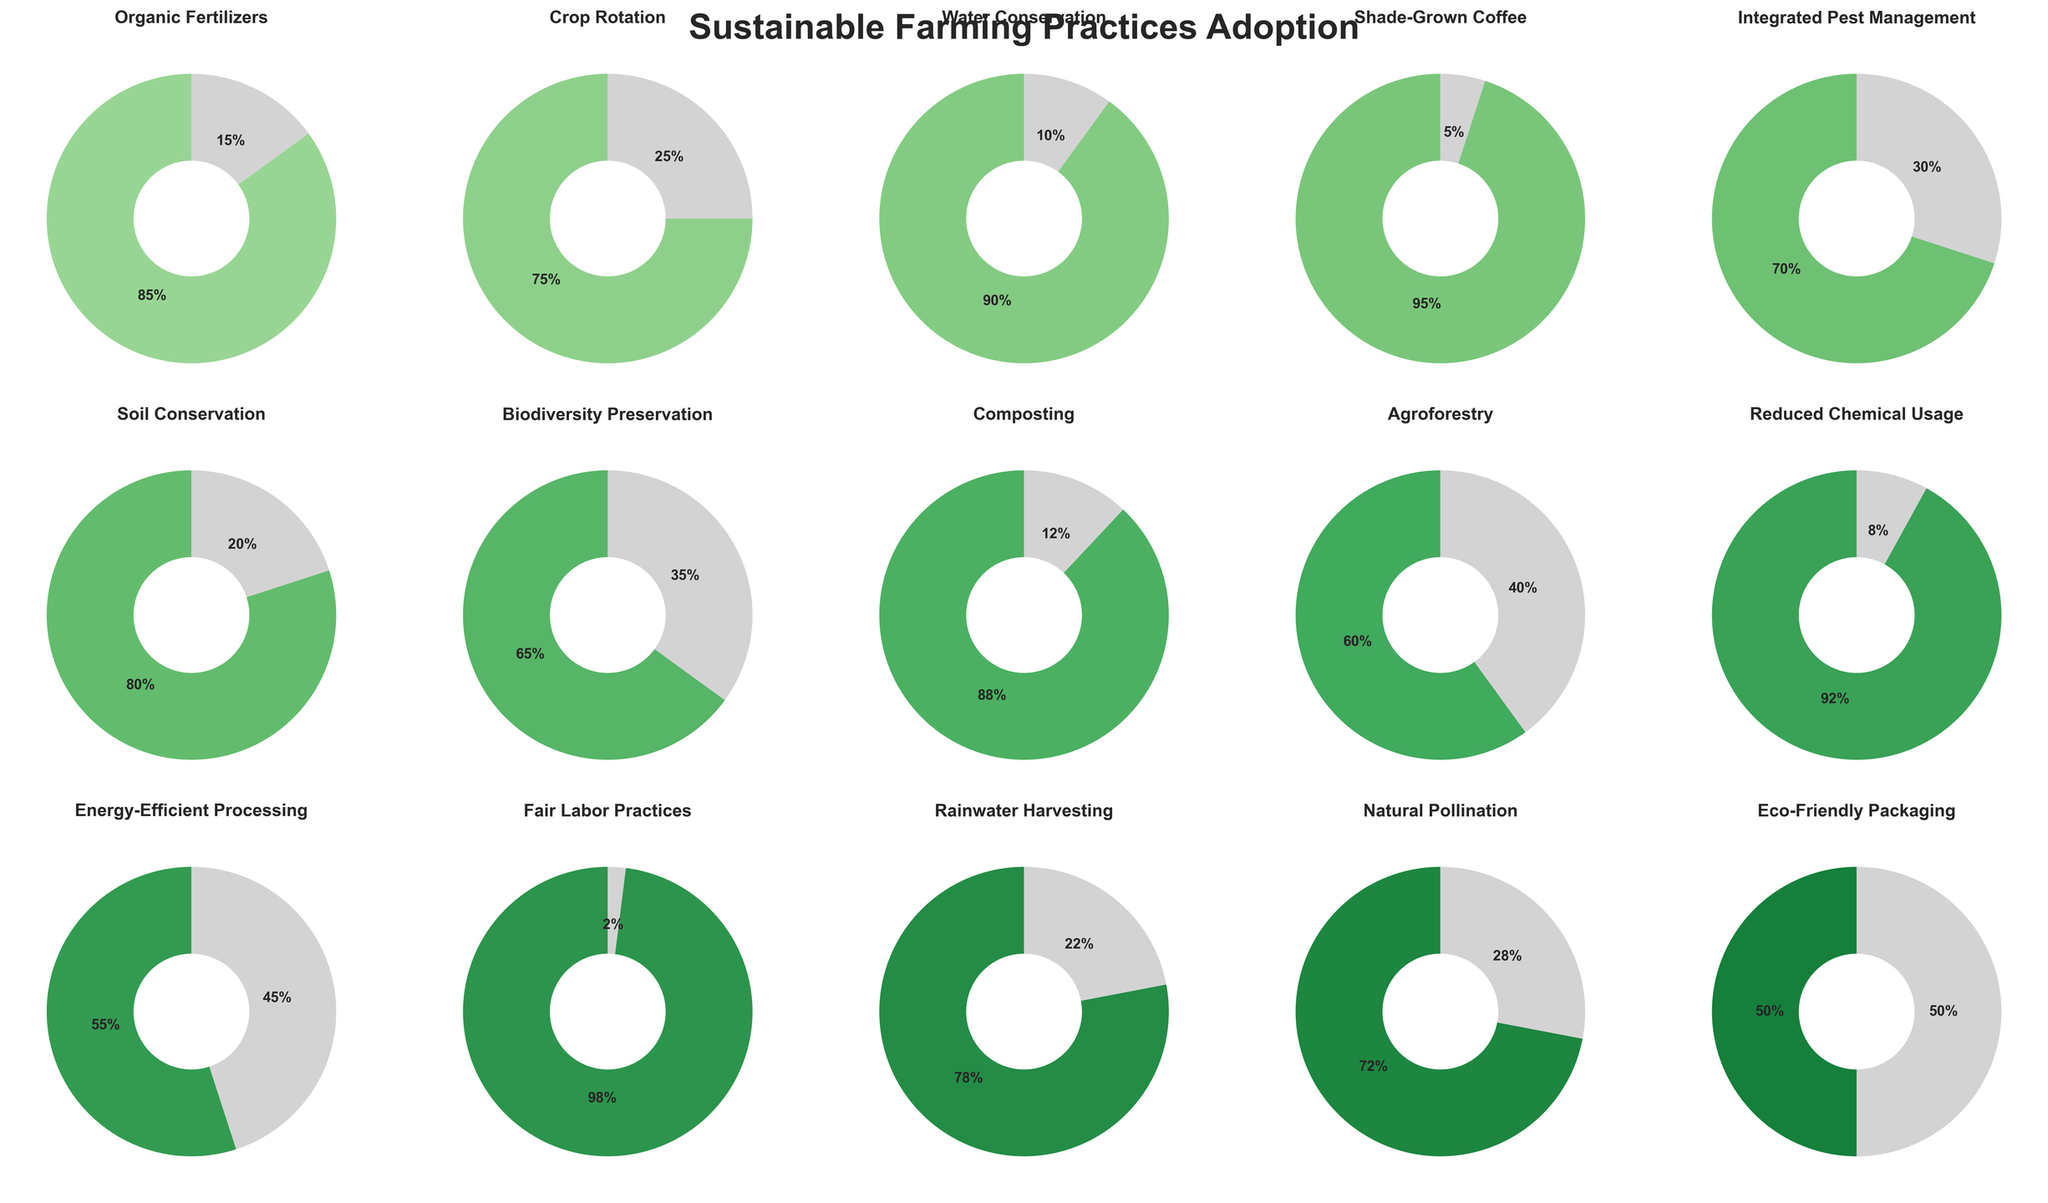Which practice has the highest adoption percentage? The pie chart for Shade-Grown Coffee shows the highest percentage at 95%.
Answer: Shade-Grown Coffee What are the three least adopted practices? The pie charts indicate Energy-Efficient Processing (55%), Eco-Friendly Packaging (50%), and Agroforestry (60%) as the least adopted practices.
Answer: Energy-Efficient Processing, Eco-Friendly Packaging, Agroforestry Which practice has a higher adoption percentage: Rainwater Harvesting or Natural Pollination? The pie charts show Rainwater Harvesting at 78% and Natural Pollination at 72%, so Rainwater Harvesting has a higher adoption percentage.
Answer: Rainwater Harvesting Calculate the average adoption percentage of the listed practices. Sum all adoption percentages and divide by the number of practices: (85 + 75 + 90 + 95 + 70 + 80 + 65 + 88 + 60 + 92 + 55 + 98 + 78 + 72 + 50) / 15 = 79%
Answer: 79% How much more percent is Organic Fertilizers adopted compared to Biodiversity Preservation? Organic Fertilizers is adopted at 85% and Biodiversity Preservation at 65%. So, 85% - 65% = 20%.
Answer: 20% Which practices have an adoption percentage greater than 90%? The pie charts show Shade-Grown Coffee (95%), Water Conservation (90%), Reduced Chemical Usage (92%), and Fair Labor Practices (98%) with an adoption percentage above 90%.
Answer: Shade-Grown Coffee, Water Conservation, Reduced Chemical Usage, Fair Labor Practices Compare the adoption of Composting with Soil Conservation and determine which one is higher. Composting has an adoption percentage of 88% while Soil Conservation has 80%. Thus, Composting is higher.
Answer: Composting Find the median adoption percentage among the given practices. Arrange the adoption percentages in ascending order: 50, 55, 60, 65, 70, 72, 75, 78, 80, 85, 88, 90, 92, 95, 98. The middle value (8th in a list of 15) is 78%.
Answer: 78% By how much does the adoption of Shade-Grown Coffee exceed Integrated Pest Management? Shade-Grown Coffee is adopted at 95% while Integrated Pest Management is at 70%. The difference is 95% - 70% = 25%.
Answer: 25% Which practices share the same color range in the pie charts? The pie charts use shades of green. Practices with close adoption percentages, such as Organic Fertilizers (85%) and Composting (88%), share similar shades of green.
Answer: Organic Fertilizers and Composting 